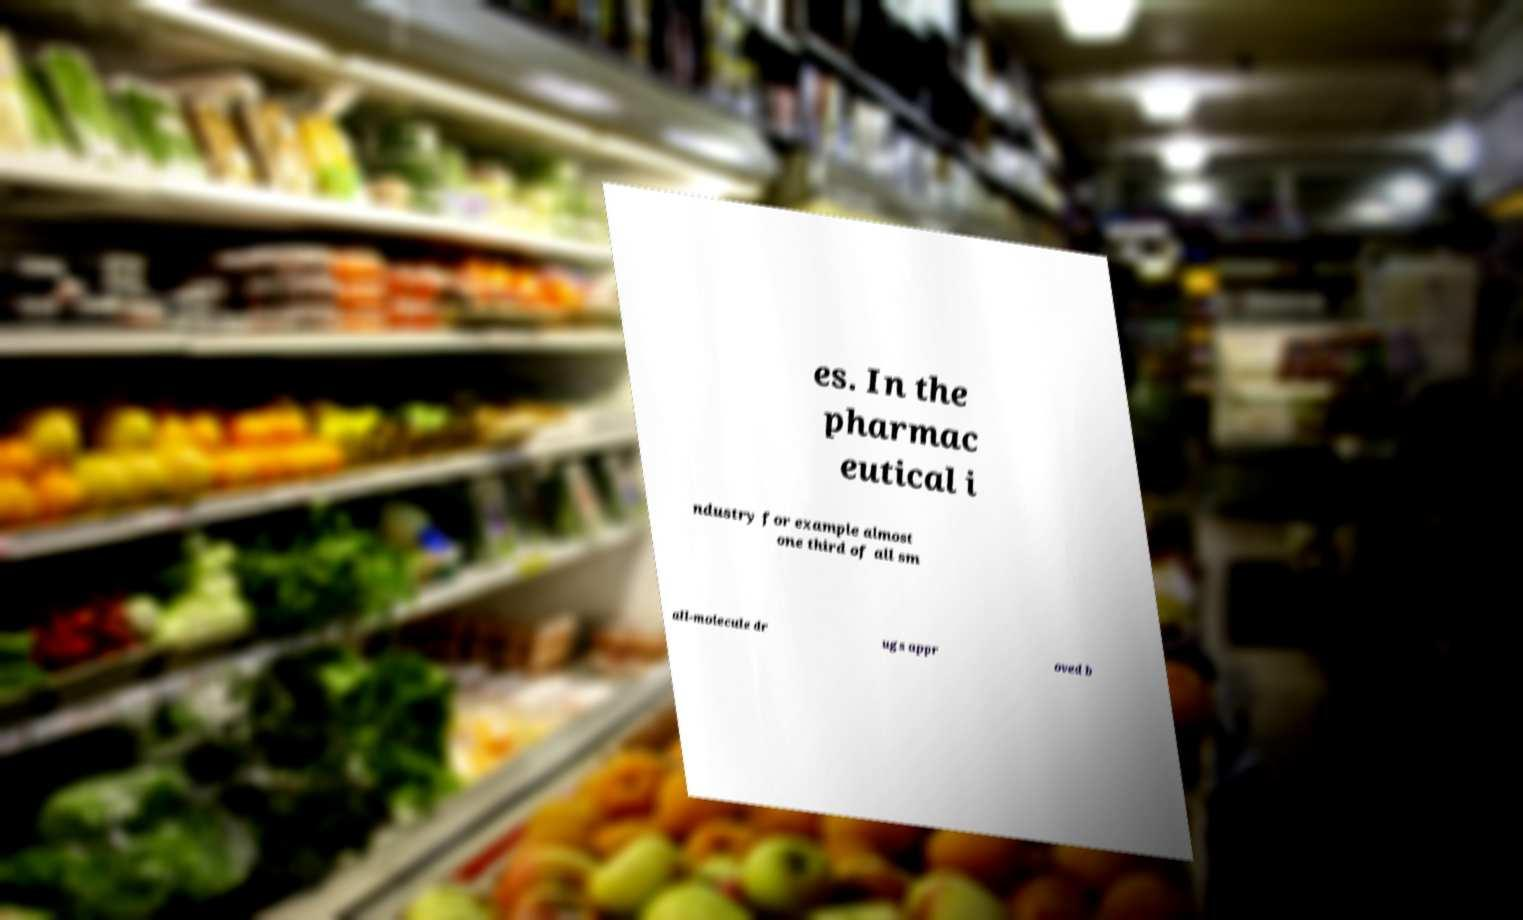I need the written content from this picture converted into text. Can you do that? es. In the pharmac eutical i ndustry for example almost one third of all sm all-molecule dr ugs appr oved b 